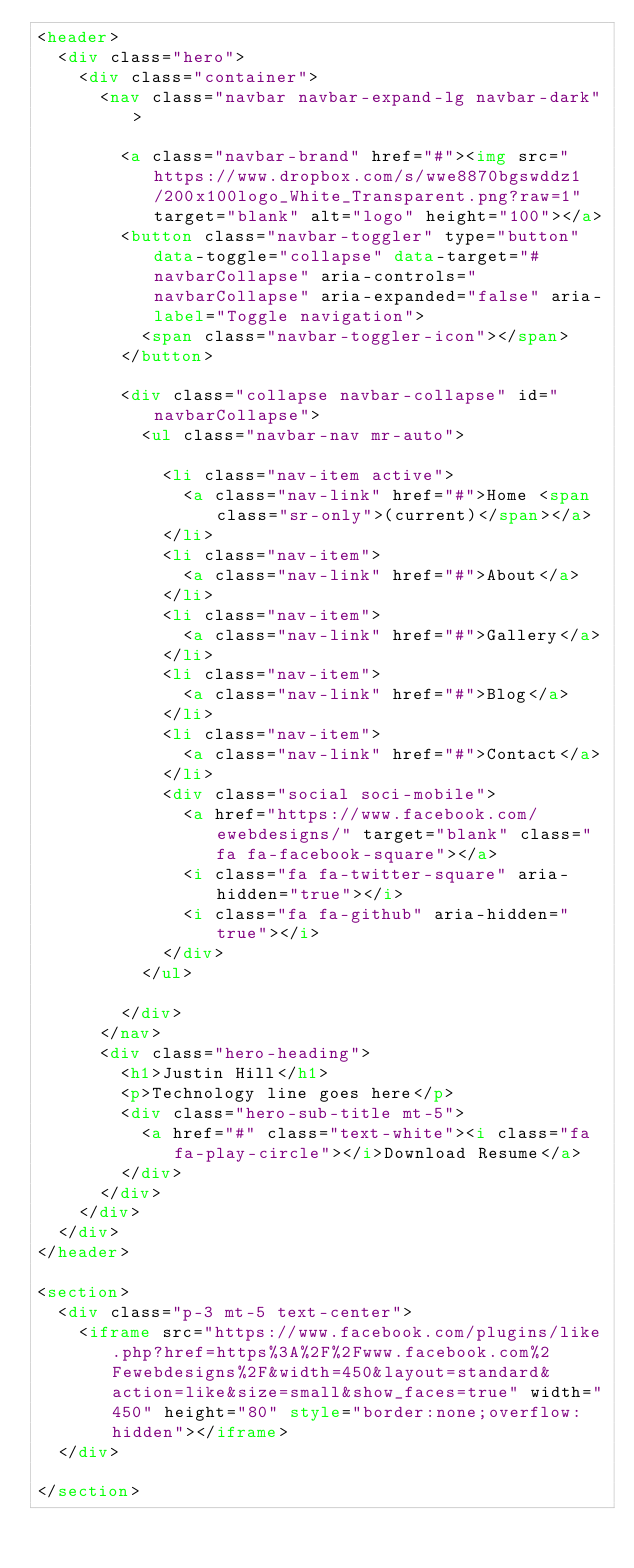Convert code to text. <code><loc_0><loc_0><loc_500><loc_500><_HTML_><header>
  <div class="hero">
    <div class="container">
      <nav class="navbar navbar-expand-lg navbar-dark">

        <a class="navbar-brand" href="#"><img src="https://www.dropbox.com/s/wwe8870bgswddz1/200x100logo_White_Transparent.png?raw=1" target="blank" alt="logo" height="100"></a>
        <button class="navbar-toggler" type="button" data-toggle="collapse" data-target="#navbarCollapse" aria-controls="navbarCollapse" aria-expanded="false" aria-label="Toggle navigation">
          <span class="navbar-toggler-icon"></span>
        </button>

        <div class="collapse navbar-collapse" id="navbarCollapse">
          <ul class="navbar-nav mr-auto">

            <li class="nav-item active">
              <a class="nav-link" href="#">Home <span class="sr-only">(current)</span></a>
            </li>
            <li class="nav-item">
              <a class="nav-link" href="#">About</a>
            </li>
            <li class="nav-item">
              <a class="nav-link" href="#">Gallery</a>
            </li>
            <li class="nav-item">
              <a class="nav-link" href="#">Blog</a>
            </li>
            <li class="nav-item">
              <a class="nav-link" href="#">Contact</a>
            </li>
            <div class="social soci-mobile">
              <a href="https://www.facebook.com/ewebdesigns/" target="blank" class="fa fa-facebook-square"></a>
              <i class="fa fa-twitter-square" aria-hidden="true"></i>
              <i class="fa fa-github" aria-hidden="true"></i>
            </div>
          </ul>

        </div>
      </nav>
      <div class="hero-heading">
        <h1>Justin Hill</h1>
        <p>Technology line goes here</p>
        <div class="hero-sub-title mt-5">
          <a href="#" class="text-white"><i class="fa fa-play-circle"></i>Download Resume</a>
        </div>
      </div>
    </div>
  </div>
</header>

<section>
  <div class="p-3 mt-5 text-center">
    <iframe src="https://www.facebook.com/plugins/like.php?href=https%3A%2F%2Fwww.facebook.com%2Fewebdesigns%2F&width=450&layout=standard&action=like&size=small&show_faces=true" width="450" height="80" style="border:none;overflow:hidden"></iframe>
  </div>

</section></code> 